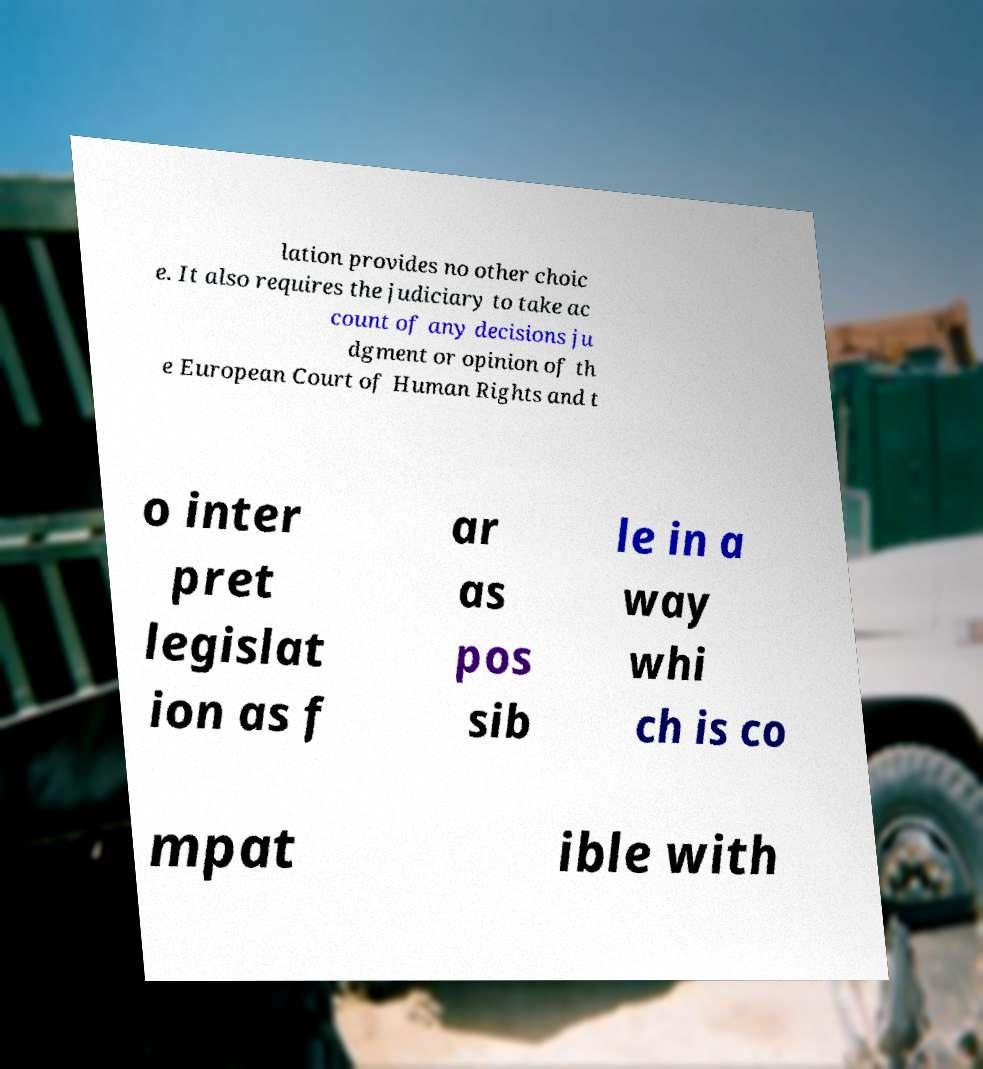I need the written content from this picture converted into text. Can you do that? lation provides no other choic e. It also requires the judiciary to take ac count of any decisions ju dgment or opinion of th e European Court of Human Rights and t o inter pret legislat ion as f ar as pos sib le in a way whi ch is co mpat ible with 